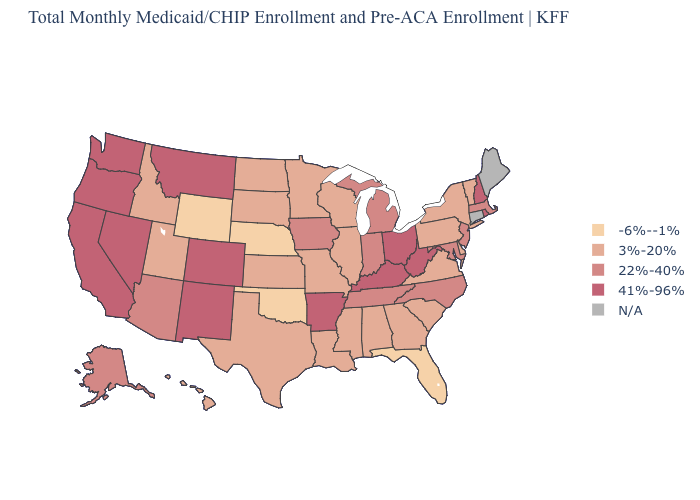Which states have the lowest value in the USA?
Concise answer only. Florida, Nebraska, Oklahoma, Wyoming. Does Nebraska have the lowest value in the MidWest?
Be succinct. Yes. Name the states that have a value in the range 41%-96%?
Short answer required. Arkansas, California, Colorado, Kentucky, Montana, Nevada, New Hampshire, New Mexico, Ohio, Oregon, Rhode Island, Washington, West Virginia. What is the value of Alabama?
Give a very brief answer. 3%-20%. Name the states that have a value in the range N/A?
Short answer required. Connecticut, Maine. Does Rhode Island have the highest value in the Northeast?
Give a very brief answer. Yes. What is the value of Maryland?
Quick response, please. 22%-40%. Name the states that have a value in the range 22%-40%?
Write a very short answer. Alaska, Arizona, Indiana, Iowa, Maryland, Massachusetts, Michigan, New Jersey, North Carolina, Tennessee. Among the states that border Florida , which have the highest value?
Quick response, please. Alabama, Georgia. What is the lowest value in the USA?
Write a very short answer. -6%--1%. What is the value of Minnesota?
Write a very short answer. 3%-20%. Name the states that have a value in the range 22%-40%?
Answer briefly. Alaska, Arizona, Indiana, Iowa, Maryland, Massachusetts, Michigan, New Jersey, North Carolina, Tennessee. What is the value of New Mexico?
Short answer required. 41%-96%. Name the states that have a value in the range N/A?
Quick response, please. Connecticut, Maine. What is the value of Oklahoma?
Keep it brief. -6%--1%. 